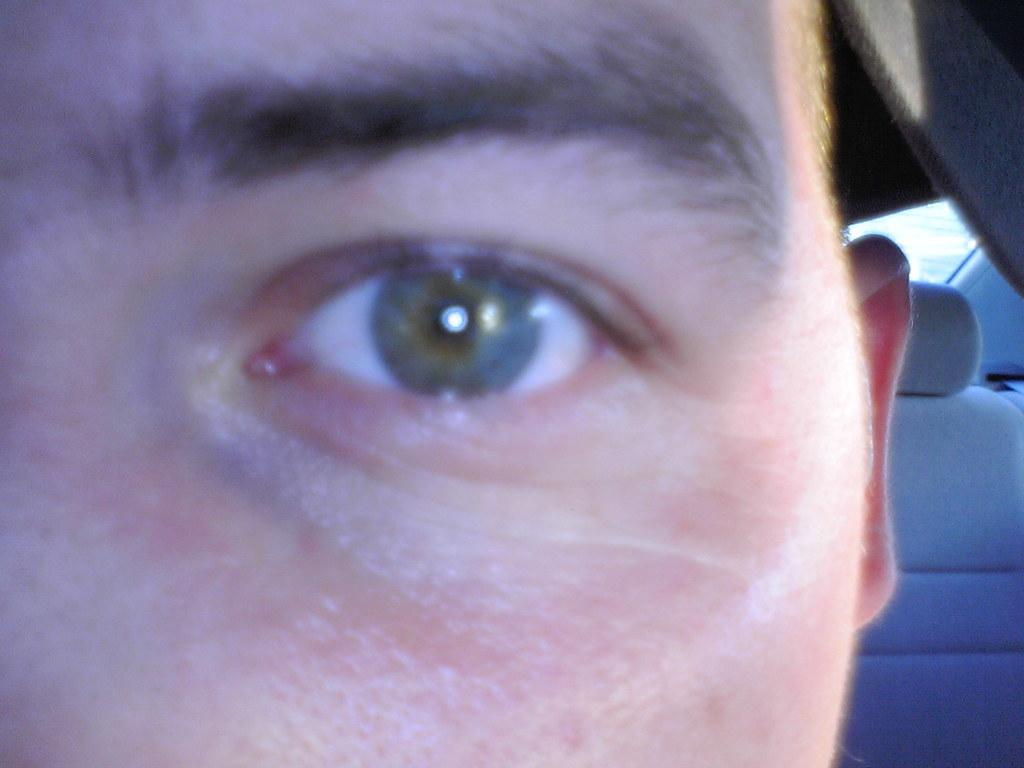What type of subject is present in the image? There is a human in the image. What can be seen in the vehicle in the image? There is a seat in a vehicle in the image. Where is the basket located in the image? There is no basket present in the image. What type of stamp can be seen on the human's forehead in the image? There is no stamp present on the human's forehead in the image. 